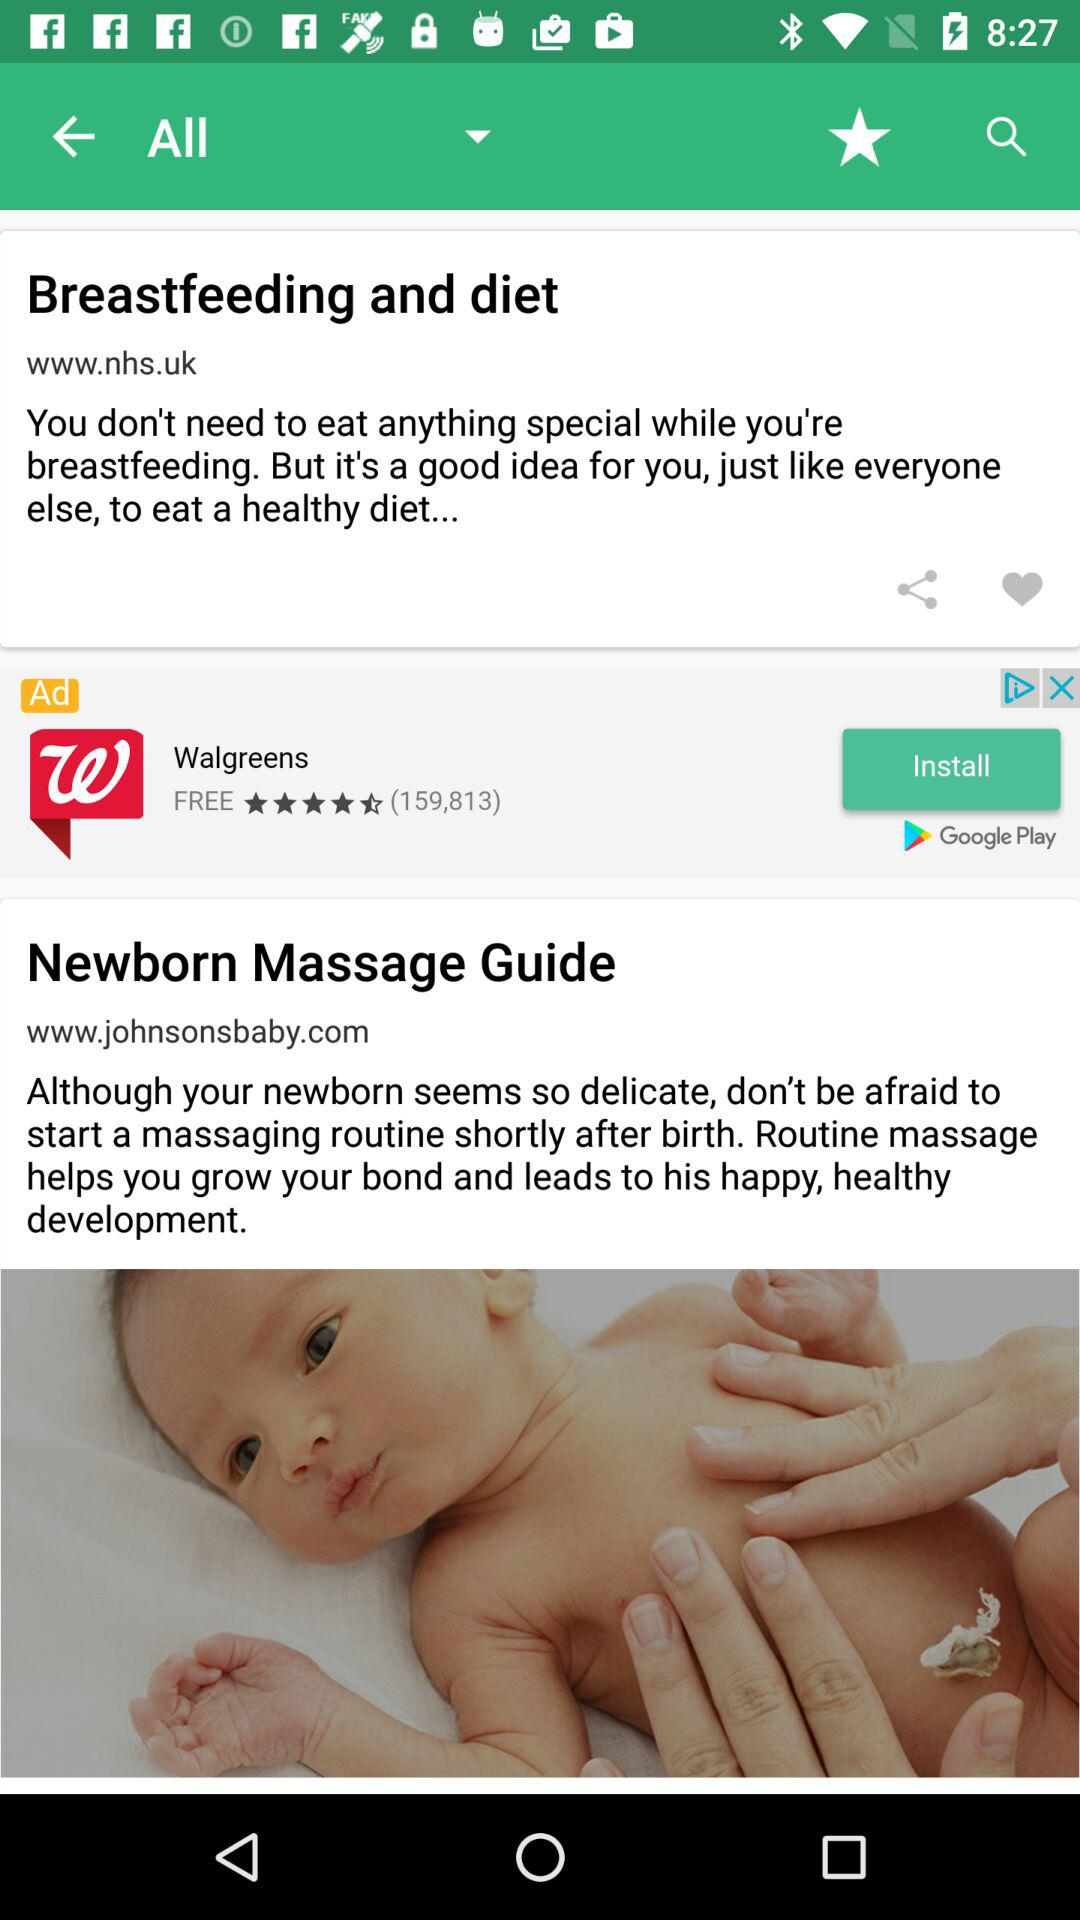What are the guides available for new-born babies? The available guide for new-born babies is "Newborn Massage Guide". 